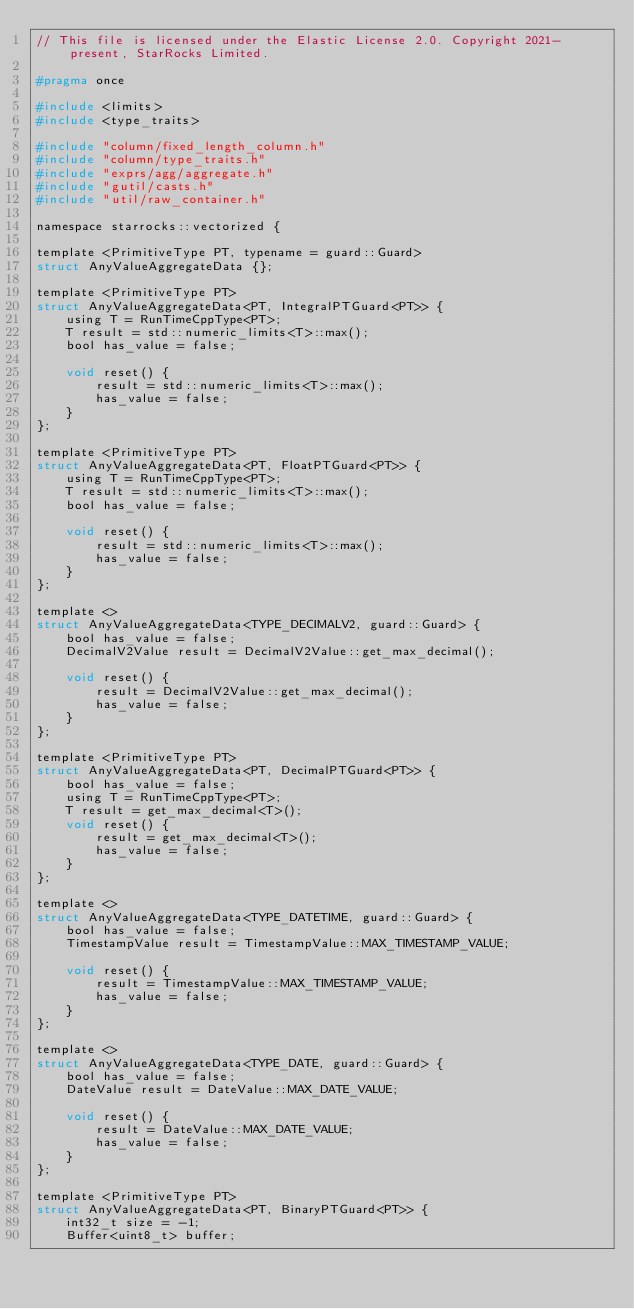Convert code to text. <code><loc_0><loc_0><loc_500><loc_500><_C_>// This file is licensed under the Elastic License 2.0. Copyright 2021-present, StarRocks Limited.

#pragma once

#include <limits>
#include <type_traits>

#include "column/fixed_length_column.h"
#include "column/type_traits.h"
#include "exprs/agg/aggregate.h"
#include "gutil/casts.h"
#include "util/raw_container.h"

namespace starrocks::vectorized {

template <PrimitiveType PT, typename = guard::Guard>
struct AnyValueAggregateData {};

template <PrimitiveType PT>
struct AnyValueAggregateData<PT, IntegralPTGuard<PT>> {
    using T = RunTimeCppType<PT>;
    T result = std::numeric_limits<T>::max();
    bool has_value = false;

    void reset() {
        result = std::numeric_limits<T>::max();
        has_value = false;
    }
};

template <PrimitiveType PT>
struct AnyValueAggregateData<PT, FloatPTGuard<PT>> {
    using T = RunTimeCppType<PT>;
    T result = std::numeric_limits<T>::max();
    bool has_value = false;

    void reset() {
        result = std::numeric_limits<T>::max();
        has_value = false;
    }
};

template <>
struct AnyValueAggregateData<TYPE_DECIMALV2, guard::Guard> {
    bool has_value = false;
    DecimalV2Value result = DecimalV2Value::get_max_decimal();

    void reset() {
        result = DecimalV2Value::get_max_decimal();
        has_value = false;
    }
};

template <PrimitiveType PT>
struct AnyValueAggregateData<PT, DecimalPTGuard<PT>> {
    bool has_value = false;
    using T = RunTimeCppType<PT>;
    T result = get_max_decimal<T>();
    void reset() {
        result = get_max_decimal<T>();
        has_value = false;
    }
};

template <>
struct AnyValueAggregateData<TYPE_DATETIME, guard::Guard> {
    bool has_value = false;
    TimestampValue result = TimestampValue::MAX_TIMESTAMP_VALUE;

    void reset() {
        result = TimestampValue::MAX_TIMESTAMP_VALUE;
        has_value = false;
    }
};

template <>
struct AnyValueAggregateData<TYPE_DATE, guard::Guard> {
    bool has_value = false;
    DateValue result = DateValue::MAX_DATE_VALUE;

    void reset() {
        result = DateValue::MAX_DATE_VALUE;
        has_value = false;
    }
};

template <PrimitiveType PT>
struct AnyValueAggregateData<PT, BinaryPTGuard<PT>> {
    int32_t size = -1;
    Buffer<uint8_t> buffer;
</code> 